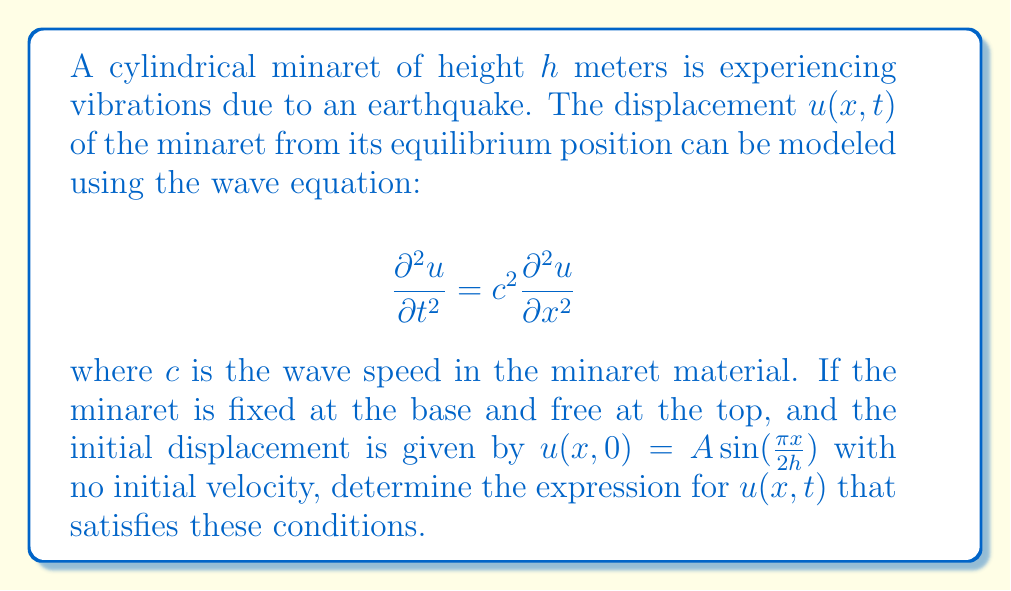Teach me how to tackle this problem. To solve this problem, we will follow these steps:

1) First, we need to identify the boundary and initial conditions:
   - Fixed base: $u(0,t) = 0$
   - Free top: $\frac{\partial u}{\partial x}(h,t) = 0$
   - Initial displacement: $u(x,0) = A\sin(\frac{\pi x}{2h})$
   - Initial velocity: $\frac{\partial u}{\partial t}(x,0) = 0$

2) The general solution to the wave equation is of the form:
   $$u(x,t) = [F(x-ct) + G(x+ct)]$$
   where $F$ and $G$ are arbitrary functions.

3) Given the boundary conditions, we can assume a solution of the form:
   $$u(x,t) = X(x)T(t)$$

4) Substituting this into the wave equation and separating variables:
   $$\frac{T''(t)}{c^2T(t)} = \frac{X''(x)}{X(x)} = -k^2$$

5) This gives us two ordinary differential equations:
   $$T''(t) + c^2k^2T(t) = 0$$
   $$X''(x) + k^2X(x) = 0$$

6) The general solutions are:
   $$T(t) = A\cos(ckt) + B\sin(ckt)$$
   $$X(x) = C\sin(kx) + D\cos(kx)$$

7) Applying the boundary condition at $x=0$:
   $$u(0,t) = 0 \implies D = 0$$

8) Applying the boundary condition at $x=h$:
   $$\frac{\partial u}{\partial x}(h,t) = 0 \implies k = \frac{\pi}{2h}$$

9) Therefore, the spatial part of the solution is:
   $$X(x) = C\sin(\frac{\pi x}{2h})$$

10) The initial condition $u(x,0) = A\sin(\frac{\pi x}{2h})$ implies that $C = A$ and $B = 0$.

11) The final solution is:
    $$u(x,t) = A\sin(\frac{\pi x}{2h})\cos(\frac{c\pi t}{2h})$$
Answer: $u(x,t) = A\sin(\frac{\pi x}{2h})\cos(\frac{c\pi t}{2h})$ 